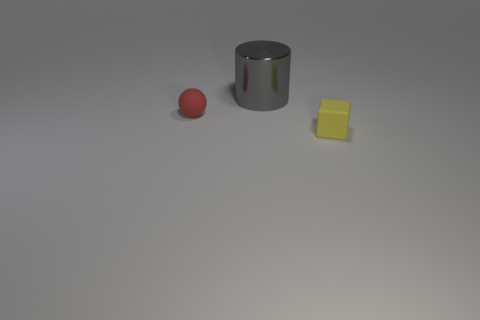Add 1 gray cylinders. How many objects exist? 4 Subtract all spheres. How many objects are left? 2 Subtract all brown rubber cubes. Subtract all tiny rubber things. How many objects are left? 1 Add 1 gray things. How many gray things are left? 2 Add 2 big gray cylinders. How many big gray cylinders exist? 3 Subtract 0 yellow cylinders. How many objects are left? 3 